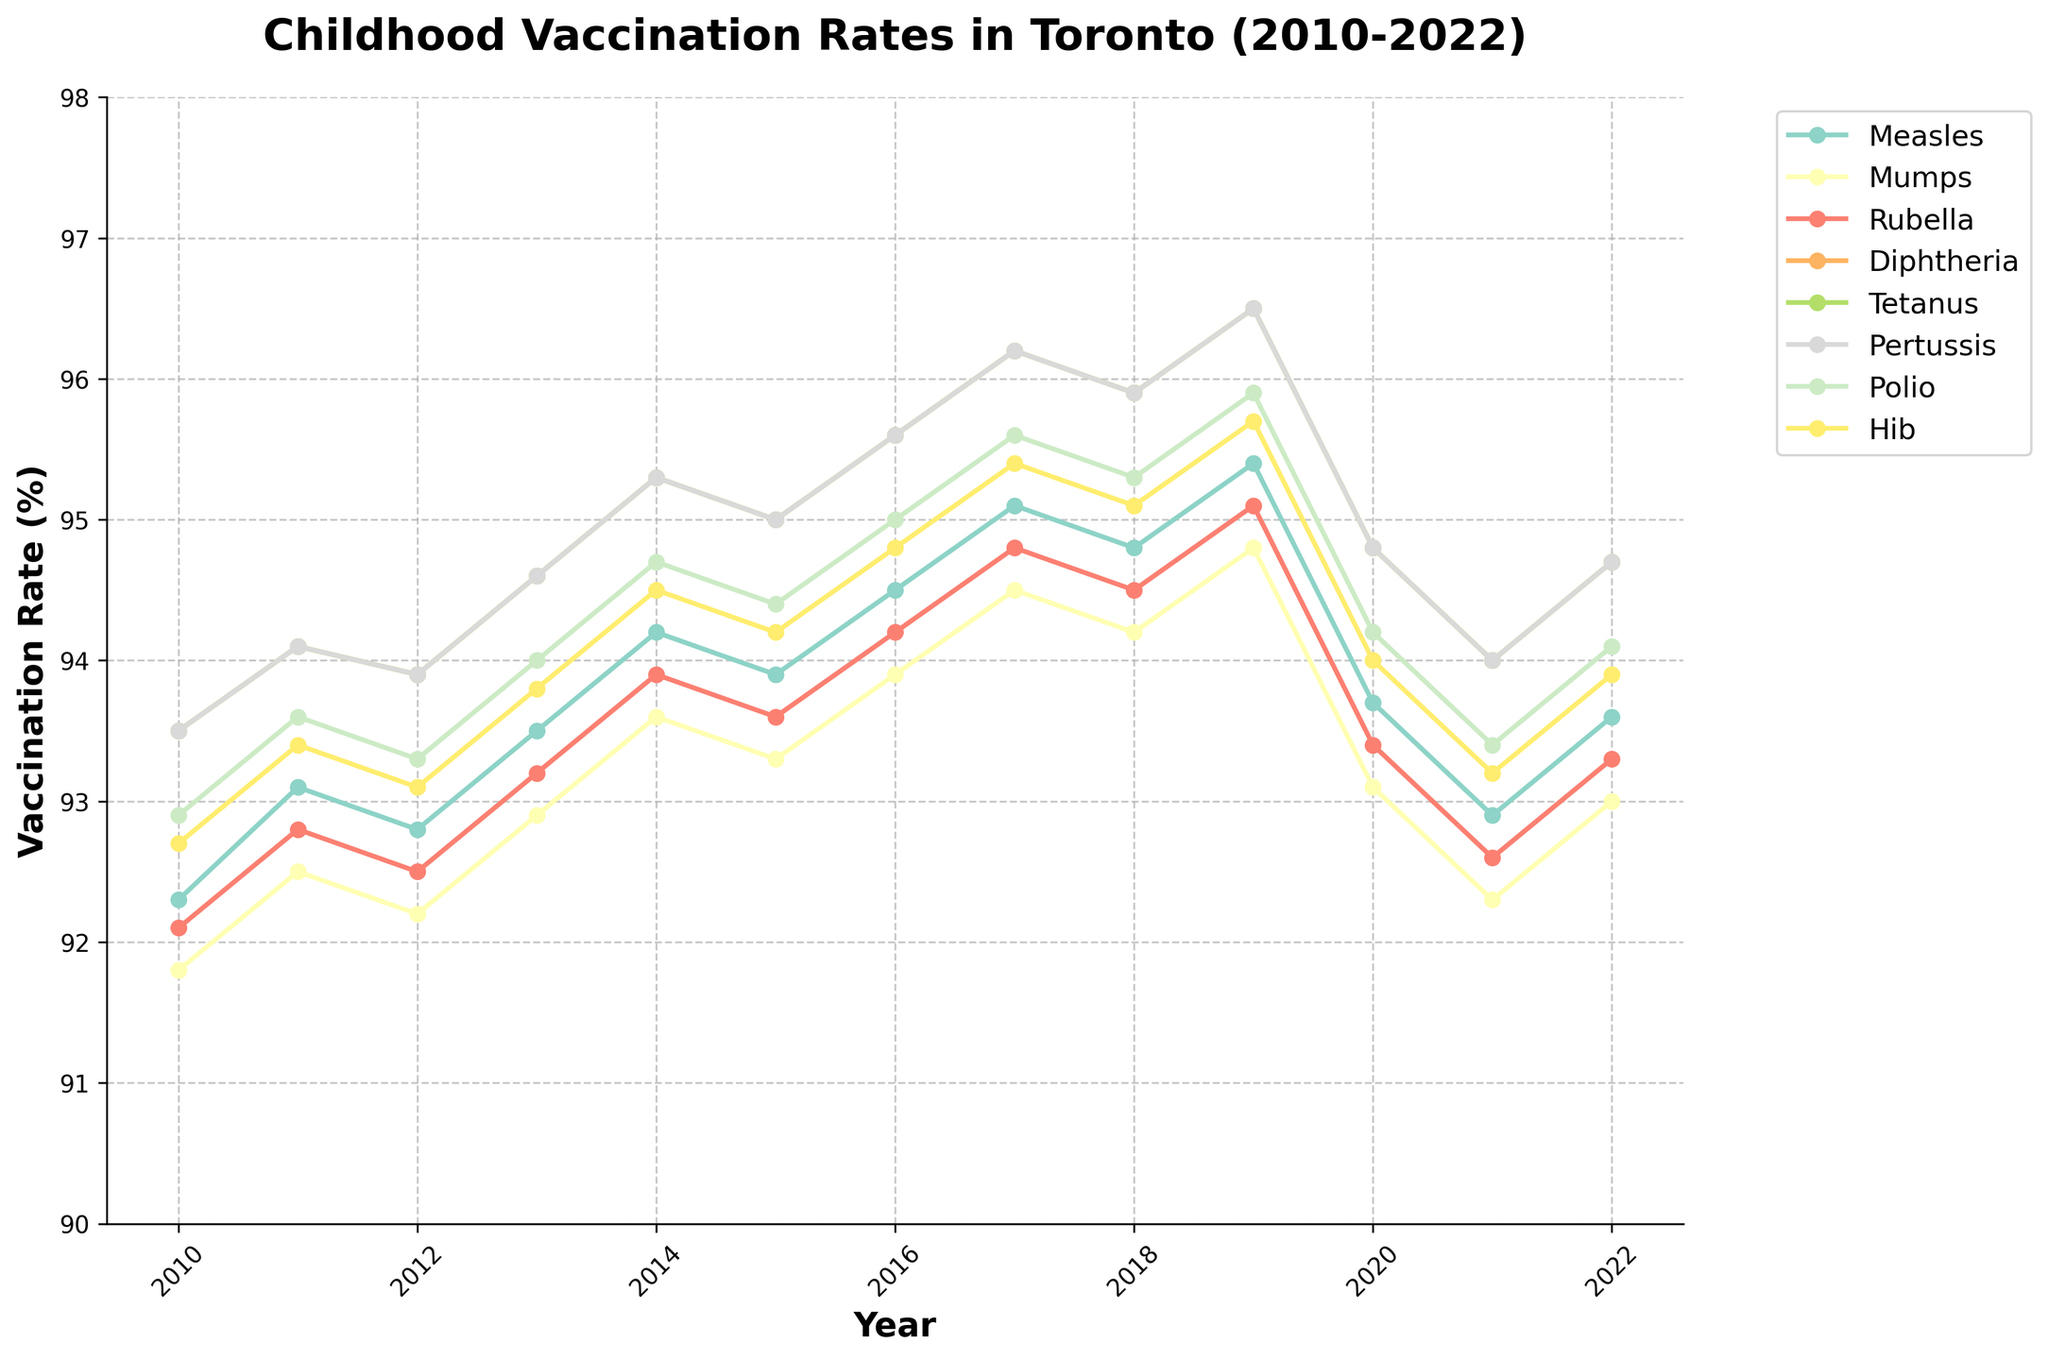What's the vaccination rate for Measles in 2022? Look at the line for Measles and find the 2022 data point.
Answer: 93.6 Which year had the highest overall vaccination rate for Diphtheria? Look at the Diphtheria line and identify the year where the line reaches its highest peak.
Answer: 2019 Compare the vaccination rates for Rubella and Tetanus in 2016. Which one is higher? Find the data points for Rubella and Tetanus in 2016 and compare the values.
Answer: Tetanus What is the average vaccination rate for Polio from 2014 to 2018? Add the vaccination rates for Polio from 2014, 2015, 2016, 2017, and 2018, then divide by 5. The values are 94.7, 94.4, 95.0, 95.6, and 95.3. Calculate (94.7 + 94.4 + 95.0 + 95.6 + 95.3) / 5 = 475 / 5.
Answer: 95.0 Did any vaccination rate drop from 2019 to 2020? If so, which one(s)? Compare the data points for all vaccinations between 2019 and 2020 and identify any that decreased.
Answer: All dropped What is the difference in the vaccination rate for Pertussis between 2012 and 2017? Find the vaccination rate for Pertussis in 2012 and 2017 and calculate the difference. The values are 93.9 and 96.2. Compute 96.2 - 93.9.
Answer: 2.3 Which vaccination had the least fluctuation in rates from 2010 to 2022? Examine the lines for all vaccinations and identify the one that remains the most stable with the least deviation across years.
Answer: Mumps What trend can be observed in the vaccination rate for Hib from 2010 to 2022? Look at the line for Hib and observe whether it generally increases, decreases, or fluctuates over time.
Answer: Generally slightly increasing What is the percentage increase in Tetanus vaccination from 2010 to 2019? Find the Tetanus rates in 2010 and 2019 and calculate the percentage increase. The values are 93.5 and 96.5. Use the formula: (96.5 - 93.5) / 93.5 * 100. ((96.5 - 93.5) / 93.5) * 100 = (3 / 93.5) * 100 ≈ 3.21%.
Answer: ~3.2% Between which consecutive years did the Measles vaccination rate increase the most? Find the differences in the Measles rates between each pair of consecutive years and identify the greatest positive difference. Compute each difference and find the maximum value.
Answer: 2016-2017 